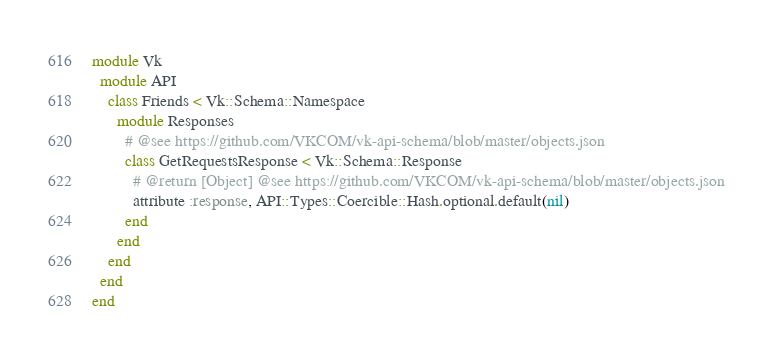<code> <loc_0><loc_0><loc_500><loc_500><_Ruby_>module Vk
  module API
    class Friends < Vk::Schema::Namespace
      module Responses
        # @see https://github.com/VKCOM/vk-api-schema/blob/master/objects.json
        class GetRequestsResponse < Vk::Schema::Response
          # @return [Object] @see https://github.com/VKCOM/vk-api-schema/blob/master/objects.json
          attribute :response, API::Types::Coercible::Hash.optional.default(nil)
        end
      end
    end
  end
end
</code> 